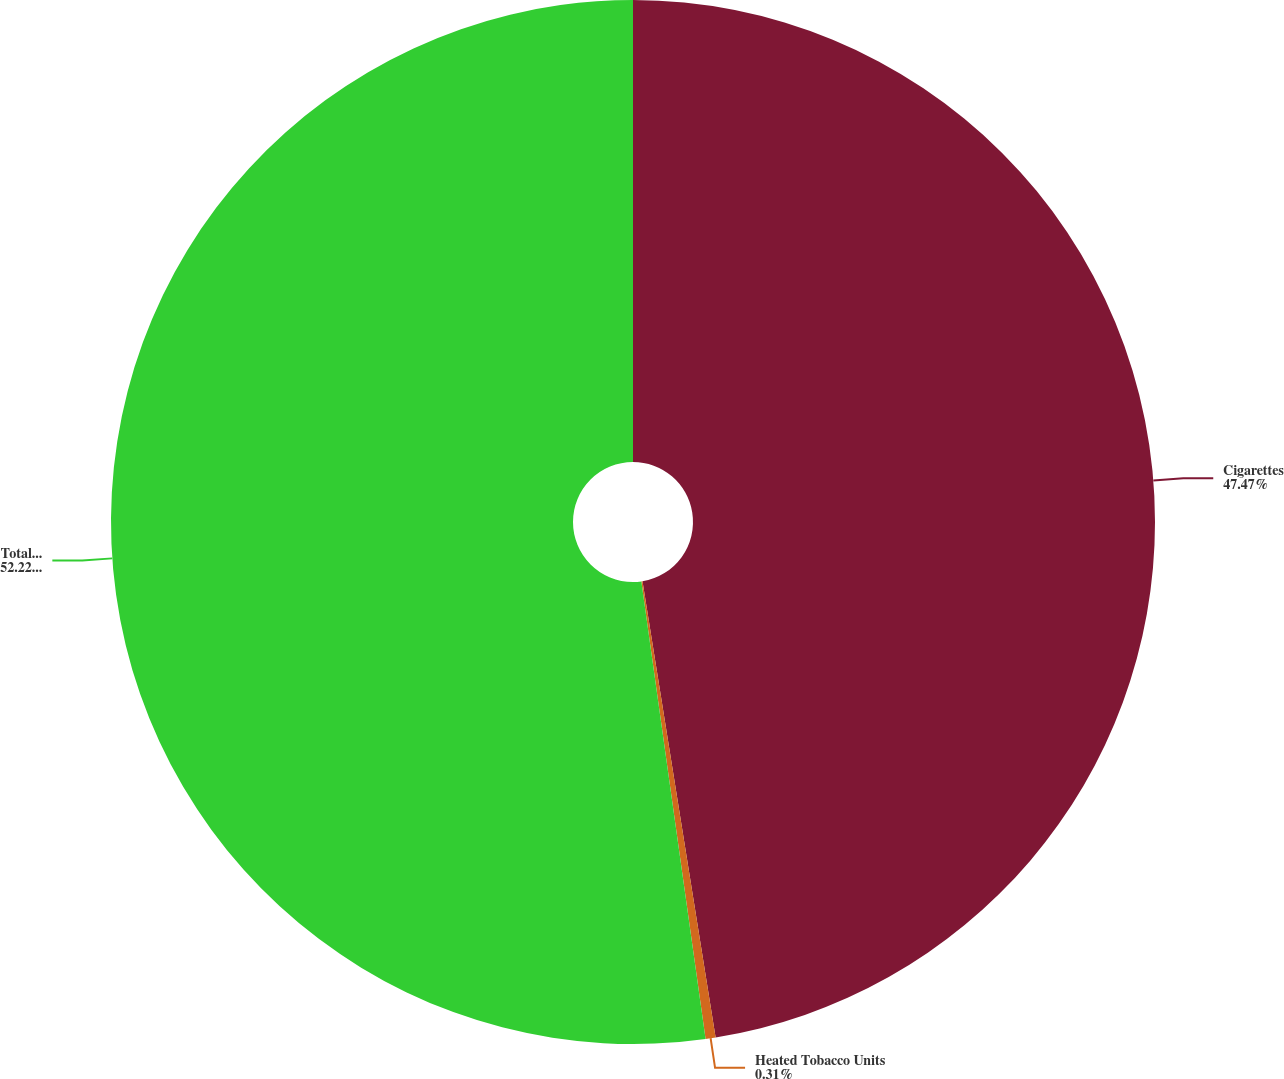Convert chart. <chart><loc_0><loc_0><loc_500><loc_500><pie_chart><fcel>Cigarettes<fcel>Heated Tobacco Units<fcel>Total Middle East & Africa<nl><fcel>47.47%<fcel>0.31%<fcel>52.22%<nl></chart> 